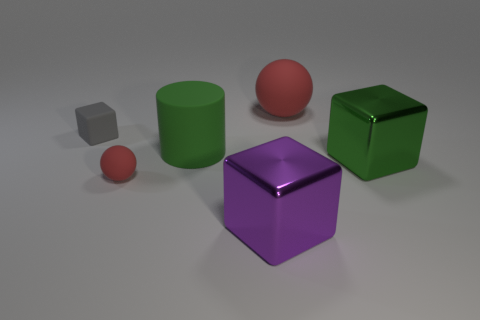Can you describe the lighting in the scene? The lighting in the scene appears soft, suggesting a diffused light source. There are subtle shadows under each object, indicating the light source is coming from above. The soft edges of the shadows suggest either a large light source or a light that has been diffused to reduce harshness. 